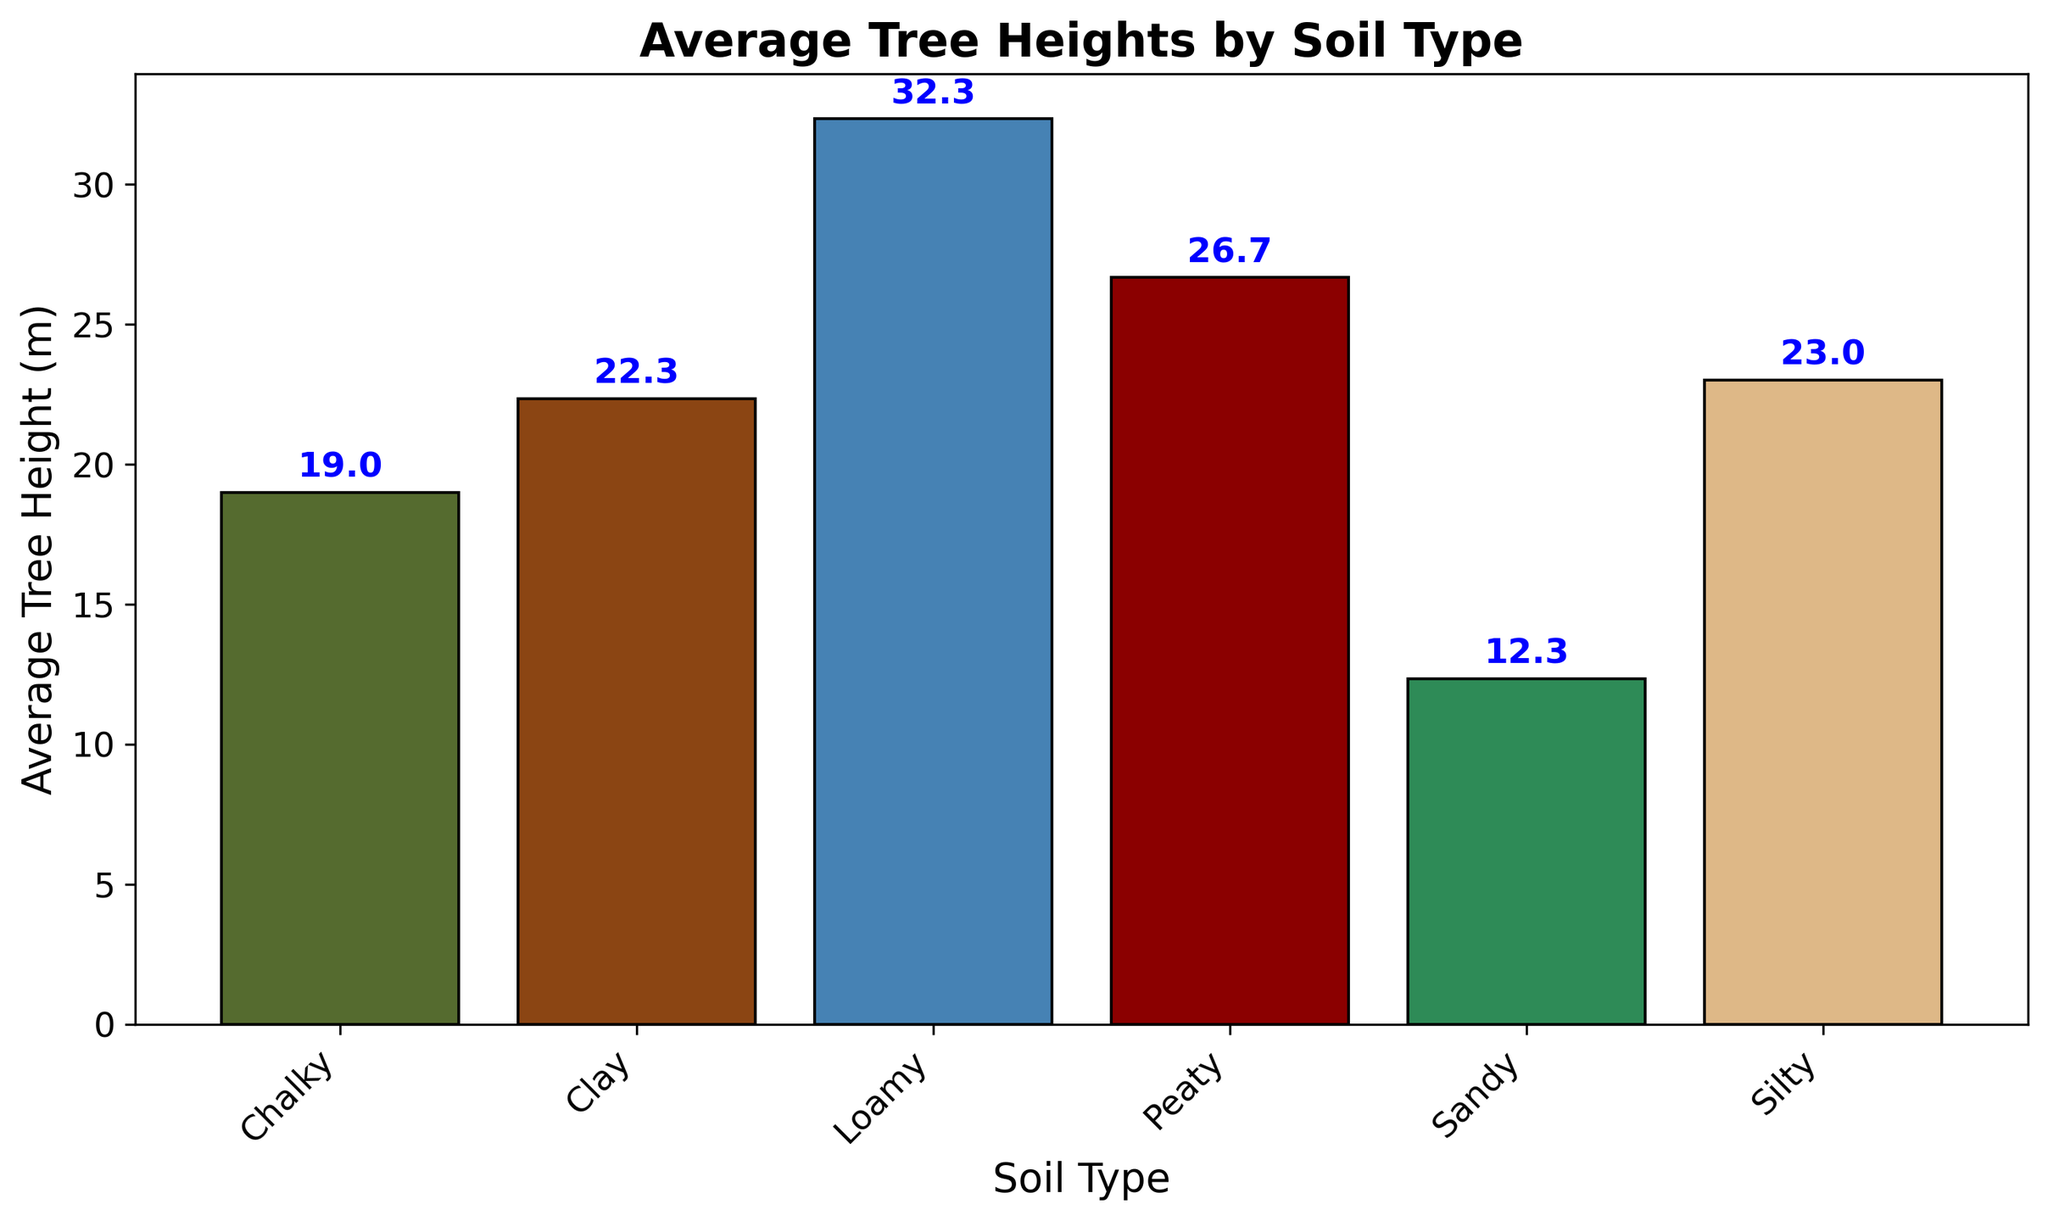What is the average tree height for Loamy soil? To find the average tree height for Loamy soil, we look at the bar corresponding to Loamy soil on the x-axis and check its height. The label on top of the bar shows the average height.
Answer: 32.3 meters Which soil type has the lowest average tree height? To determine the soil type with the lowest average tree height, we compare the heights of all the bars and identify the shortest one. The label on top of the shortest bar shows the average height.
Answer: Sandy How much higher is the average tree height for Loamy soil compared to Sandy soil? To find this difference, identify the heights of the Loamy and Sandy soil bars from the chart. The height for Loamy soil is 32.3 meters, and for Sandy soil, it is 12.3 meters. Subtract the average height of Sandy soil from that of Loamy soil.
Answer: 20.0 meters Rank the soil types from highest to lowest average tree height. To rank the soil types, list them according to the heights of their respective bars from tallest to shortest.
Answer: Loamy, Peaty, Silty, Clay, Chalky, Sandy What is the combined average tree height for Clay and Silty soils? First, locate the bars for Clay and Silty soils and note their heights, which are 22.3 meters and 23.0 meters, respectively. Add these two heights together to get the combined average.
Answer: 45.3 meters Which two soil types have average tree heights closest to each other? To answer this, compare the heights of all neighboring and distant bars to find the smallest difference. The bars for Silty and Clay soils have heights of 23.0 meters and 22.3 meters, respectively, indicating the smallest difference.
Answer: Silty and Clay How does the average tree height for Peaty soil compare to Chalky soil? To compare these two soil types, look at the bars for Peaty and Chalky soils and note their heights. Peaty soil has an average tree height of 26.7 meters while Chalky soil has 19.0 meters, indicating that Peaty is taller.
Answer: Peaty is taller than Chalky What is the percentage difference in average tree height between the tallest and shortest soil types? First, identify the tallest (Loamy, 32.3 meters) and shortest (Sandy, 12.3 meters) average tree heights. Calculate the difference between them (32.3 - 12.3 = 20.0 meters), and then divide by the shortest height (20.0/12.3). Multiply by 100 to get the percentage difference.
Answer: 162.6% Which color bar represents the average tree height of Peaty soil? Look for the bar labeled Peaty along the x-axis and note its color. Peaty soil is depicted in a maroon color.
Answer: Maroon What can be inferred about the relationship between soil type and tree height from the figure? By analyzing the different heights of the bars, we observe that Loamy and Peaty soils, which are higher in average tree height, indicate a positive effect of these soil types on tree growth, while Sandy and Chalky soils show lower average heights, indicating less favorable growth conditions.
Answer: Certain soil types like Loamy and Peaty are more favorable for tree growth than Sandy and Chalky 